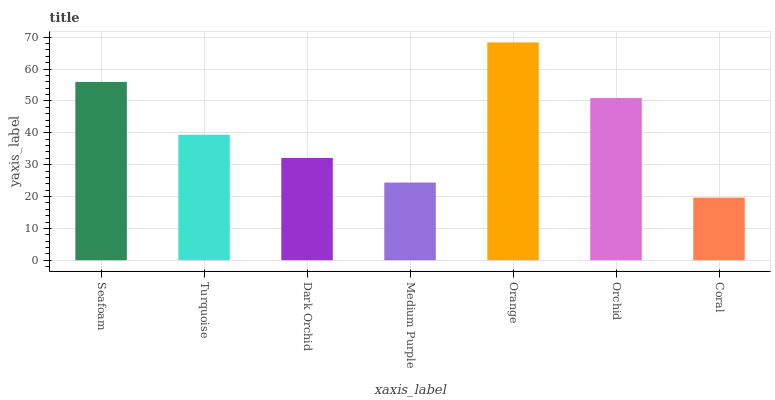Is Coral the minimum?
Answer yes or no. Yes. Is Orange the maximum?
Answer yes or no. Yes. Is Turquoise the minimum?
Answer yes or no. No. Is Turquoise the maximum?
Answer yes or no. No. Is Seafoam greater than Turquoise?
Answer yes or no. Yes. Is Turquoise less than Seafoam?
Answer yes or no. Yes. Is Turquoise greater than Seafoam?
Answer yes or no. No. Is Seafoam less than Turquoise?
Answer yes or no. No. Is Turquoise the high median?
Answer yes or no. Yes. Is Turquoise the low median?
Answer yes or no. Yes. Is Seafoam the high median?
Answer yes or no. No. Is Orchid the low median?
Answer yes or no. No. 